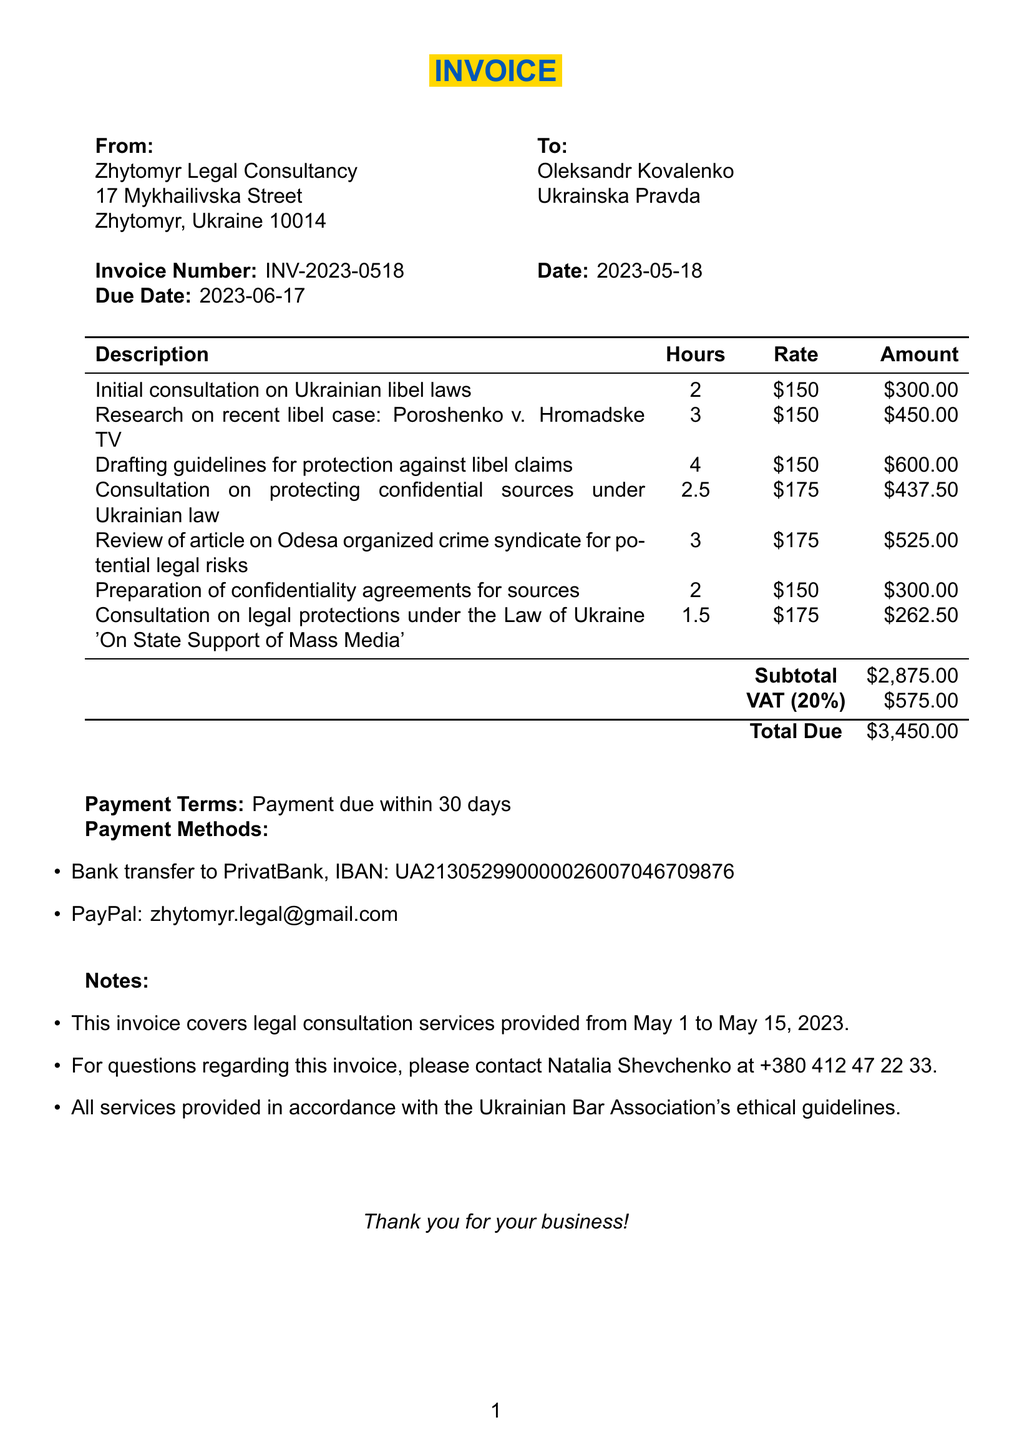What is the invoice number? The invoice number is specified in the document, designated as INV-2023-0518.
Answer: INV-2023-0518 What is the date of the invoice? The date is clearly mentioned in the invoice details, which is 2023-05-18.
Answer: 2023-05-18 Who is the service provider? The service provider is listed at the top of the invoice, identified as Zhytomyr Legal Consultancy.
Answer: Zhytomyr Legal Consultancy What is the subtotal amount? The subtotal is provided in the calculation section of the invoice, which amounts to 2875.
Answer: 2875 How many hours were billed for the research on the libel case? The number of hours for this specific service is explicitly stated as 3 hours in the itemized list.
Answer: 3 What is the VAT rate applied to the invoice? The VAT rate is mentioned in the invoice and is set at 20 percent.
Answer: 20% What is the total due amount on the invoice? The total due amount adds up all charges including the VAT, totaling to 3450.
Answer: 3450 How long is the payment term for this invoice? The payment terms are specified directly; payment is due within 30 days.
Answer: 30 days Who can be contacted for questions regarding the invoice? The contact person for inquiries is provided in the notes section, namely Natalia Shevchenko.
Answer: Natalia Shevchenko 